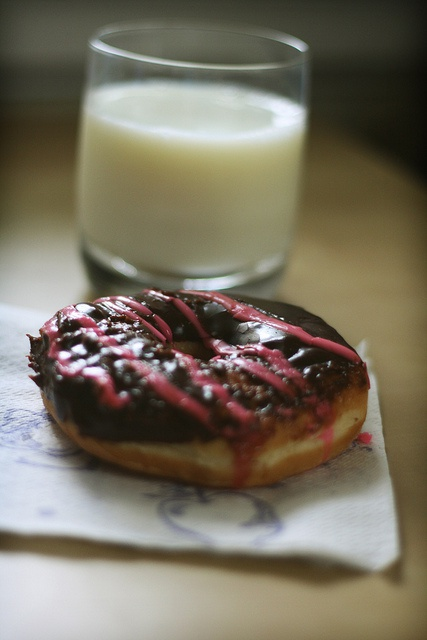Describe the objects in this image and their specific colors. I can see dining table in black, olive, lightgray, and darkgray tones, cup in black, gray, olive, lightgray, and darkgray tones, and donut in black, maroon, and brown tones in this image. 